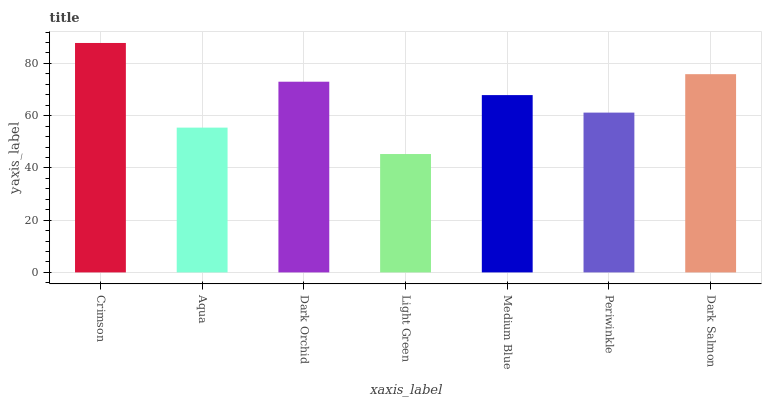Is Crimson the maximum?
Answer yes or no. Yes. Is Aqua the minimum?
Answer yes or no. No. Is Aqua the maximum?
Answer yes or no. No. Is Crimson greater than Aqua?
Answer yes or no. Yes. Is Aqua less than Crimson?
Answer yes or no. Yes. Is Aqua greater than Crimson?
Answer yes or no. No. Is Crimson less than Aqua?
Answer yes or no. No. Is Medium Blue the high median?
Answer yes or no. Yes. Is Medium Blue the low median?
Answer yes or no. Yes. Is Aqua the high median?
Answer yes or no. No. Is Periwinkle the low median?
Answer yes or no. No. 